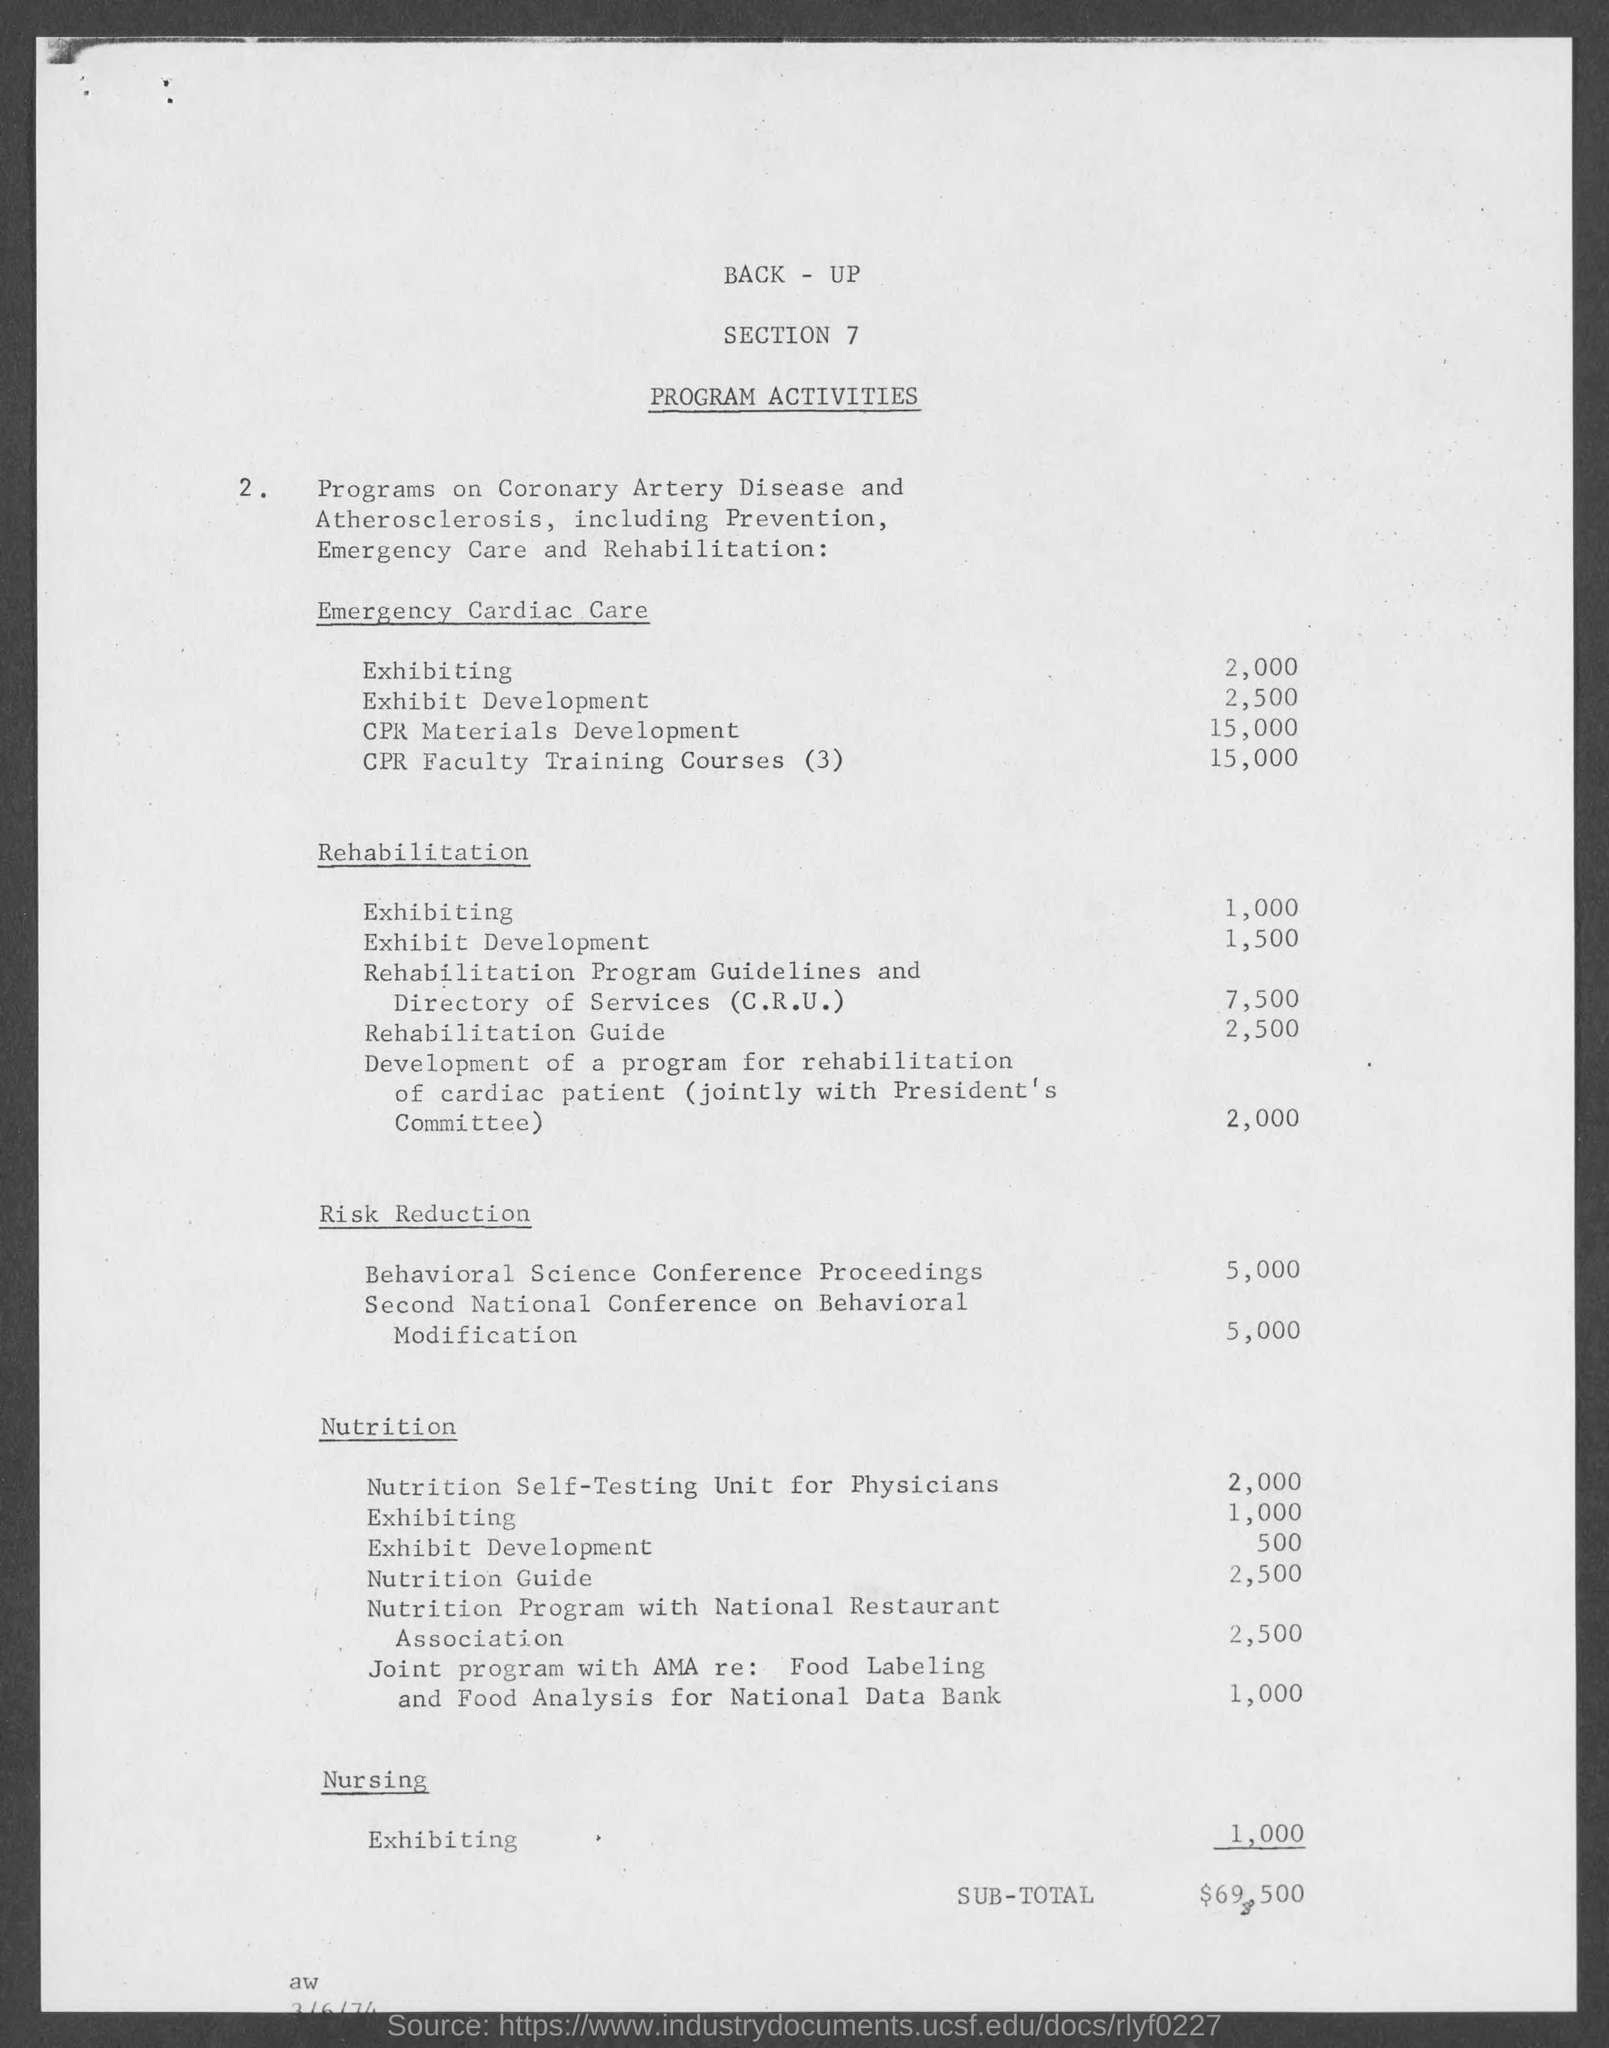How many "Exhibiting" in Emergency cardiac care?
Offer a terse response. 2,000. How many "Exhibit Development" in Emergency cardiac care?
Provide a short and direct response. 2,500. How many "CPR Materials development" in Emergency cardiac care?
Give a very brief answer. 15,000. How many "CPR Faculty Training Courses (3)" in Emergency cardiac care?
Offer a terse response. 15,000. How many "Exhibiting" in Rehabilitation?
Your answer should be very brief. 1,000. How many "Exhibit Development" in Rehabilitation?
Ensure brevity in your answer.  1,500. How many "Rehabilitation Guide" in Rehabilitation?
Ensure brevity in your answer.  2,500. How many "Exhibiting" in Nursing?
Make the answer very short. 1,000. How many "Rehabilitation Program Guidelines and Directory of Services (C.R.U.)" in Rehabilitation?
Keep it short and to the point. 7,500. What is the Sub-Total?
Provide a short and direct response. $69,500. 